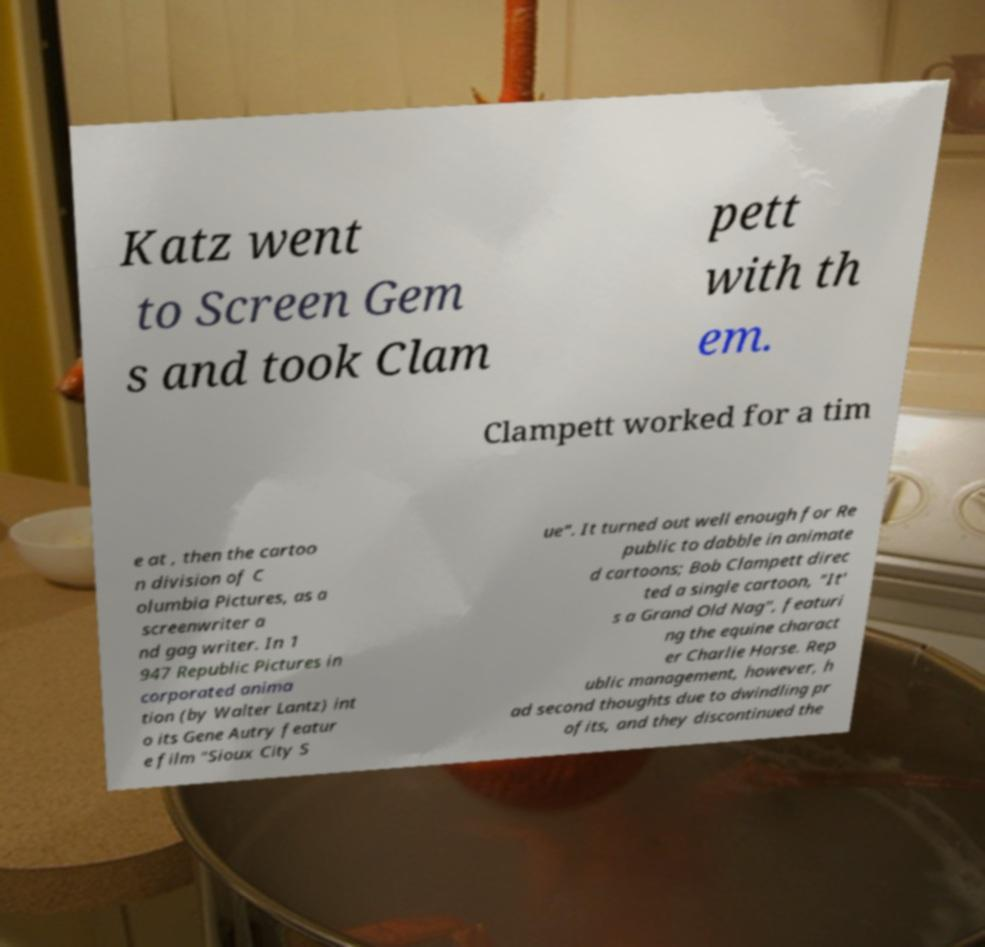Can you accurately transcribe the text from the provided image for me? Katz went to Screen Gem s and took Clam pett with th em. Clampett worked for a tim e at , then the cartoo n division of C olumbia Pictures, as a screenwriter a nd gag writer. In 1 947 Republic Pictures in corporated anima tion (by Walter Lantz) int o its Gene Autry featur e film "Sioux City S ue". It turned out well enough for Re public to dabble in animate d cartoons; Bob Clampett direc ted a single cartoon, "It' s a Grand Old Nag", featuri ng the equine charact er Charlie Horse. Rep ublic management, however, h ad second thoughts due to dwindling pr ofits, and they discontinued the 